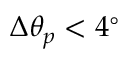Convert formula to latex. <formula><loc_0><loc_0><loc_500><loc_500>\Delta \theta _ { p } < 4 ^ { \circ }</formula> 